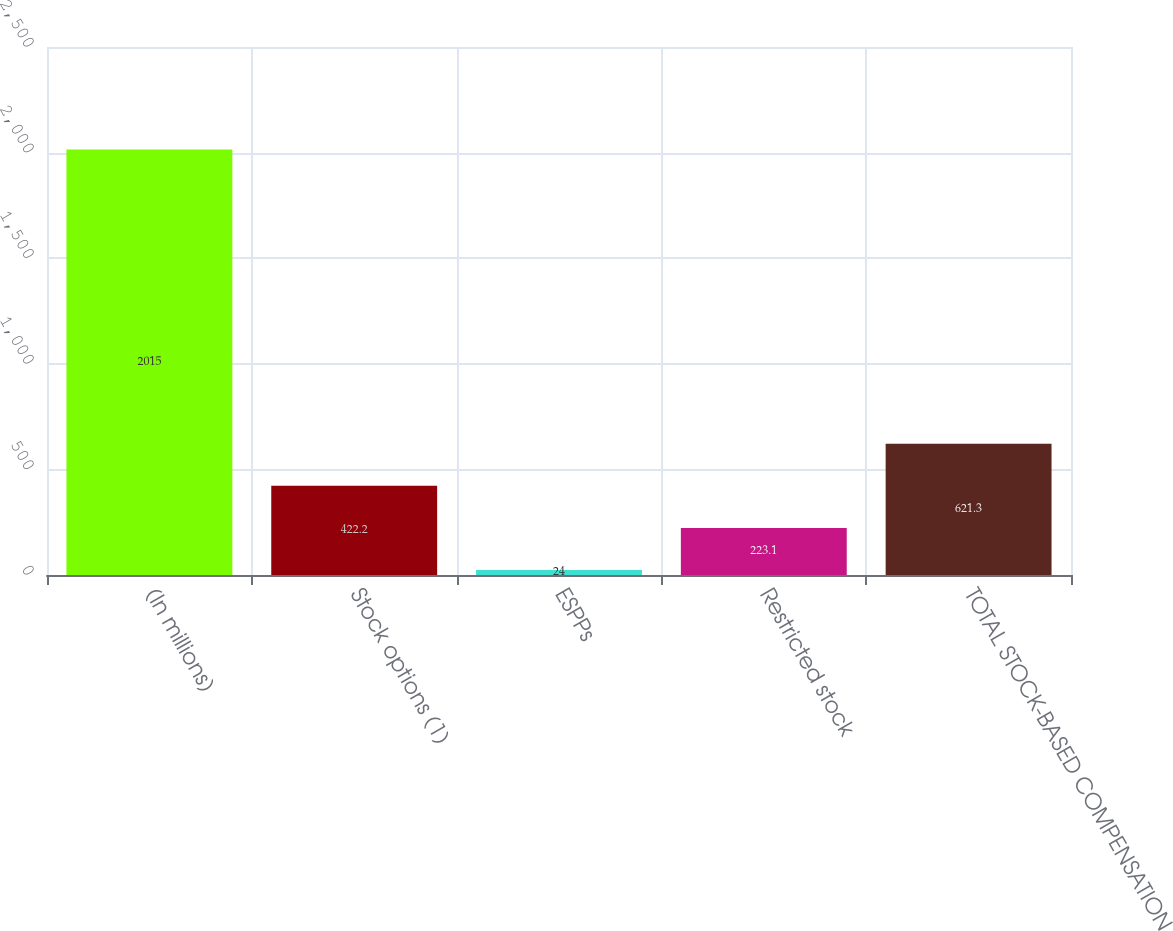Convert chart to OTSL. <chart><loc_0><loc_0><loc_500><loc_500><bar_chart><fcel>(In millions)<fcel>Stock options (1)<fcel>ESPPs<fcel>Restricted stock<fcel>TOTAL STOCK-BASED COMPENSATION<nl><fcel>2015<fcel>422.2<fcel>24<fcel>223.1<fcel>621.3<nl></chart> 